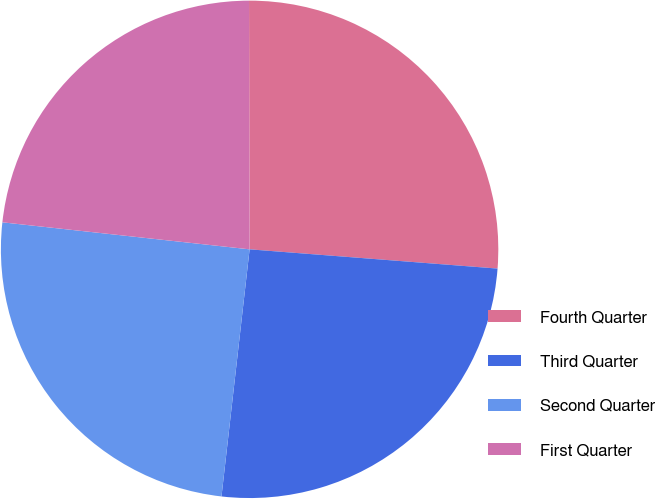Convert chart. <chart><loc_0><loc_0><loc_500><loc_500><pie_chart><fcel>Fourth Quarter<fcel>Third Quarter<fcel>Second Quarter<fcel>First Quarter<nl><fcel>26.27%<fcel>25.57%<fcel>24.93%<fcel>23.23%<nl></chart> 